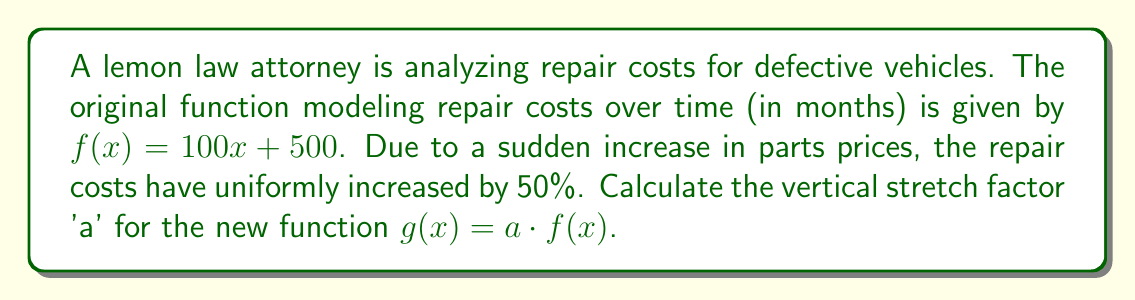Can you answer this question? To find the vertical stretch factor 'a', we need to follow these steps:

1) The original function is $f(x) = 100x + 500$

2) We're told that repair costs have uniformly increased by 50%. This means that every y-value of the original function needs to be multiplied by 1.5 (because 100% + 50% = 150% = 1.5)

3) The new function $g(x)$ is defined as $a \cdot f(x)$, where 'a' is the vertical stretch factor

4) This means:
   $g(x) = a \cdot (100x + 500)$

5) For this to represent a 50% increase, 'a' must equal 1.5:
   $g(x) = 1.5 \cdot (100x + 500)$

6) We can verify:
   $g(x) = 1.5 \cdot (100x + 500)$
   $g(x) = 150x + 750$

   Indeed, every term is 1.5 times its original value.

Therefore, the vertical stretch factor 'a' is 1.5.
Answer: $a = 1.5$ 